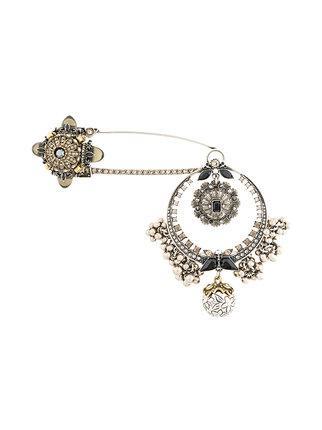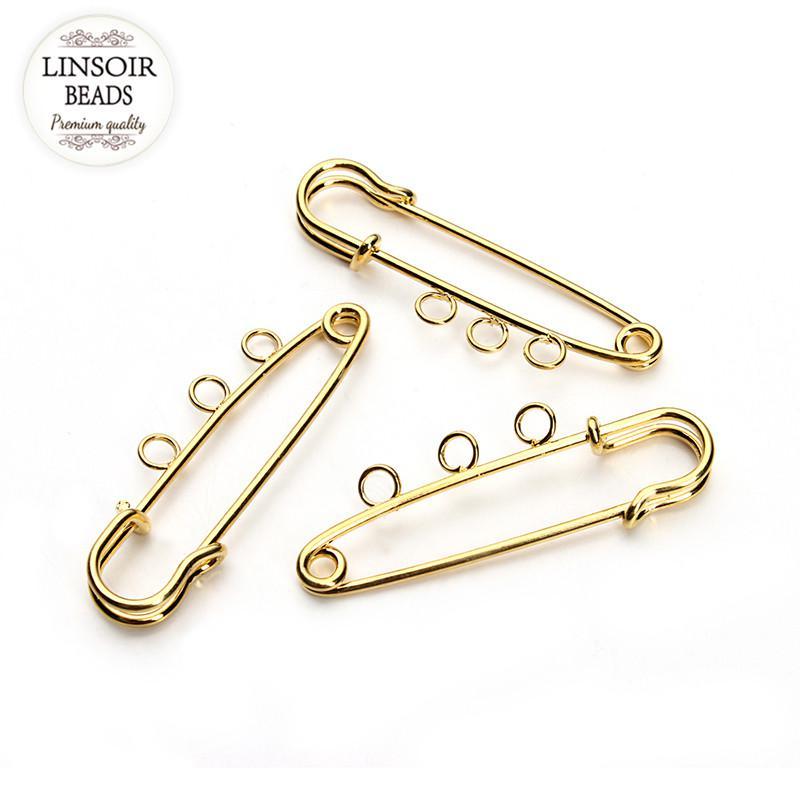The first image is the image on the left, the second image is the image on the right. Examine the images to the left and right. Is the description "Most of the fasteners are gold." accurate? Answer yes or no. Yes. 